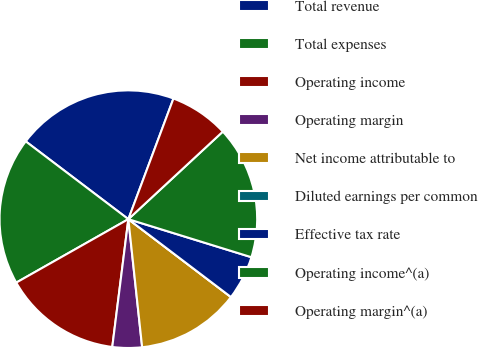<chart> <loc_0><loc_0><loc_500><loc_500><pie_chart><fcel>Total revenue<fcel>Total expenses<fcel>Operating income<fcel>Operating margin<fcel>Net income attributable to<fcel>Diluted earnings per common<fcel>Effective tax rate<fcel>Operating income^(a)<fcel>Operating margin^(a)<nl><fcel>20.37%<fcel>18.52%<fcel>14.81%<fcel>3.7%<fcel>12.96%<fcel>0.0%<fcel>5.56%<fcel>16.67%<fcel>7.41%<nl></chart> 